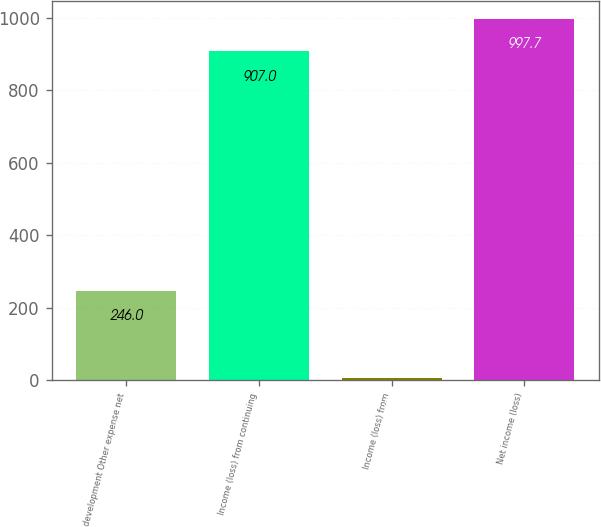<chart> <loc_0><loc_0><loc_500><loc_500><bar_chart><fcel>development Other expense net<fcel>Income (loss) from continuing<fcel>Income (loss) from<fcel>Net income (loss)<nl><fcel>246<fcel>907<fcel>5<fcel>997.7<nl></chart> 